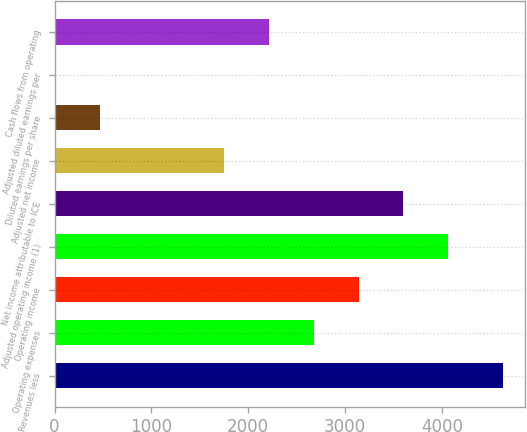Convert chart. <chart><loc_0><loc_0><loc_500><loc_500><bar_chart><fcel>Revenues less<fcel>Operating expenses<fcel>Operating income<fcel>Adjusted operating income (1)<fcel>Net income attributable to ICE<fcel>Adjusted net income<fcel>Diluted earnings per share<fcel>Adjusted diluted earnings per<fcel>Cash flows from operating<nl><fcel>4629<fcel>2677.22<fcel>3139.82<fcel>4065.03<fcel>3602.43<fcel>1752<fcel>465.56<fcel>2.95<fcel>2214.61<nl></chart> 